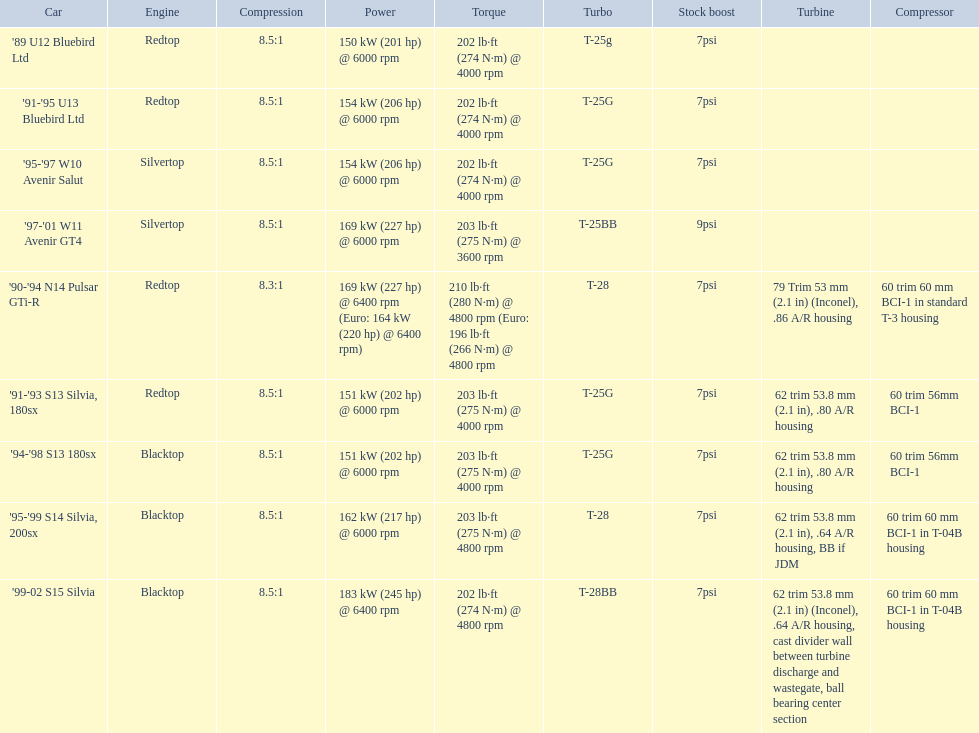What are all the car models? '89 U12 Bluebird Ltd, '91-'95 U13 Bluebird Ltd, '95-'97 W10 Avenir Salut, '97-'01 W11 Avenir GT4, '90-'94 N14 Pulsar GTi-R, '91-'93 S13 Silvia, 180sx, '94-'98 S13 180sx, '95-'99 S14 Silvia, 200sx, '99-02 S15 Silvia. What is their assessed power? 150 kW (201 hp) @ 6000 rpm, 154 kW (206 hp) @ 6000 rpm, 154 kW (206 hp) @ 6000 rpm, 169 kW (227 hp) @ 6000 rpm, 169 kW (227 hp) @ 6400 rpm (Euro: 164 kW (220 hp) @ 6400 rpm), 151 kW (202 hp) @ 6000 rpm, 151 kW (202 hp) @ 6000 rpm, 162 kW (217 hp) @ 6000 rpm, 183 kW (245 hp) @ 6400 rpm. Which automobile has the most power? '99-02 S15 Silvia. 